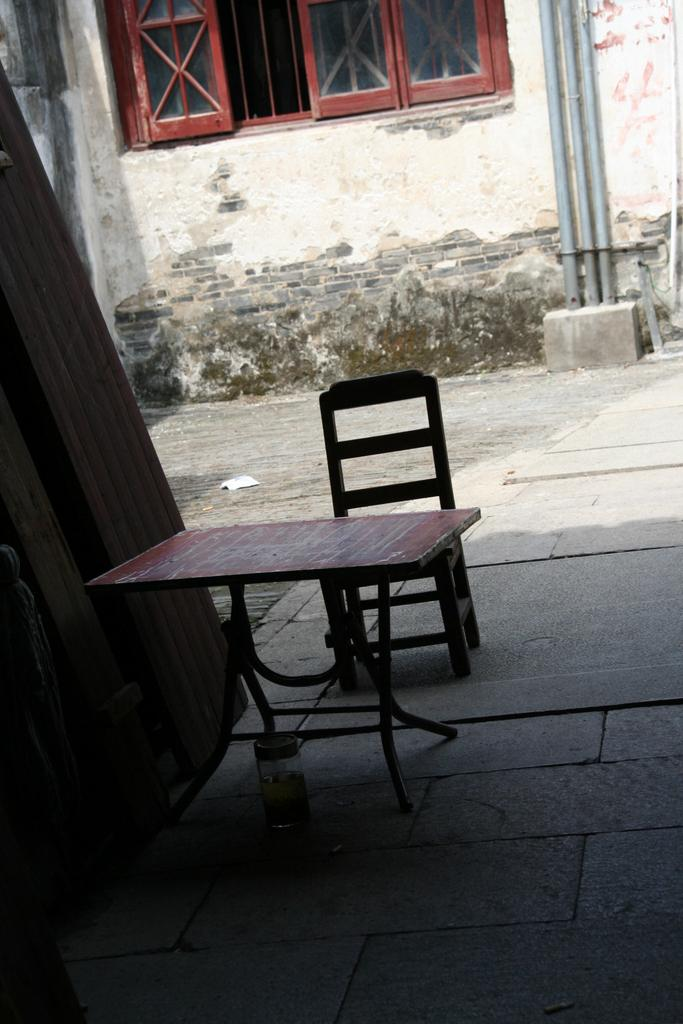What is located in the center of the image? There is a table and a chair in the center of the image. What can be seen at the top side of the image? There is a window at the top side of the image. What country is visible through the window in the image? There is no country visible through the window in the image; it is not mentioned in the provided facts. 